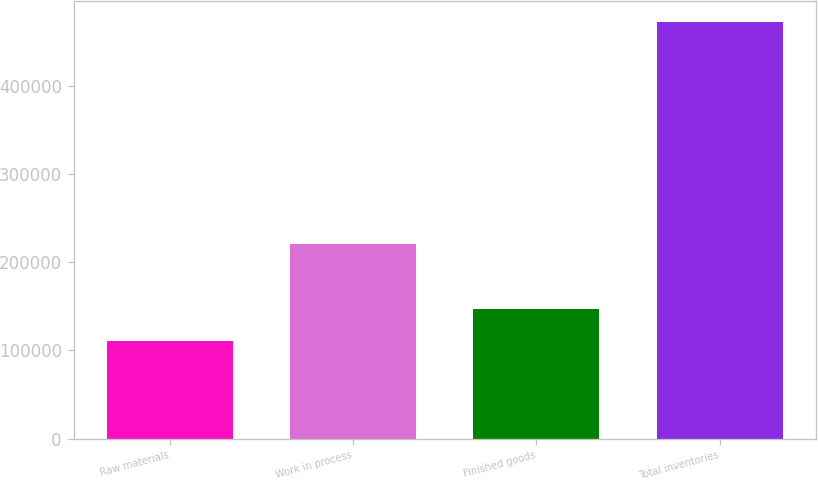Convert chart to OTSL. <chart><loc_0><loc_0><loc_500><loc_500><bar_chart><fcel>Raw materials<fcel>Work in process<fcel>Finished goods<fcel>Total inventories<nl><fcel>110389<fcel>221137<fcel>146579<fcel>472292<nl></chart> 